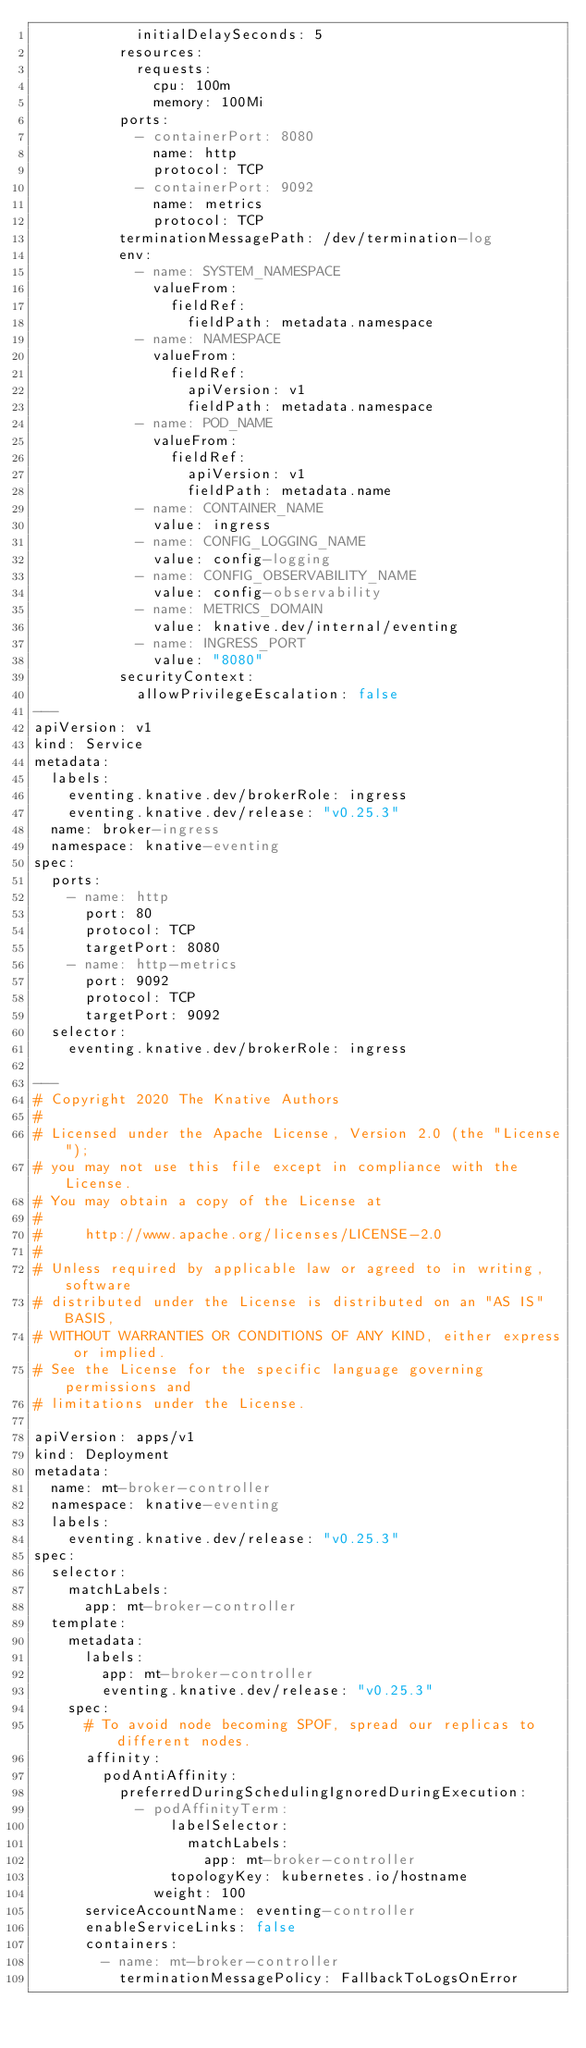Convert code to text. <code><loc_0><loc_0><loc_500><loc_500><_YAML_>            initialDelaySeconds: 5
          resources:
            requests:
              cpu: 100m
              memory: 100Mi
          ports:
            - containerPort: 8080
              name: http
              protocol: TCP
            - containerPort: 9092
              name: metrics
              protocol: TCP
          terminationMessagePath: /dev/termination-log
          env:
            - name: SYSTEM_NAMESPACE
              valueFrom:
                fieldRef:
                  fieldPath: metadata.namespace
            - name: NAMESPACE
              valueFrom:
                fieldRef:
                  apiVersion: v1
                  fieldPath: metadata.namespace
            - name: POD_NAME
              valueFrom:
                fieldRef:
                  apiVersion: v1
                  fieldPath: metadata.name
            - name: CONTAINER_NAME
              value: ingress
            - name: CONFIG_LOGGING_NAME
              value: config-logging
            - name: CONFIG_OBSERVABILITY_NAME
              value: config-observability
            - name: METRICS_DOMAIN
              value: knative.dev/internal/eventing
            - name: INGRESS_PORT
              value: "8080"
          securityContext:
            allowPrivilegeEscalation: false
---
apiVersion: v1
kind: Service
metadata:
  labels:
    eventing.knative.dev/brokerRole: ingress
    eventing.knative.dev/release: "v0.25.3"
  name: broker-ingress
  namespace: knative-eventing
spec:
  ports:
    - name: http
      port: 80
      protocol: TCP
      targetPort: 8080
    - name: http-metrics
      port: 9092
      protocol: TCP
      targetPort: 9092
  selector:
    eventing.knative.dev/brokerRole: ingress

---
# Copyright 2020 The Knative Authors
#
# Licensed under the Apache License, Version 2.0 (the "License");
# you may not use this file except in compliance with the License.
# You may obtain a copy of the License at
#
#     http://www.apache.org/licenses/LICENSE-2.0
#
# Unless required by applicable law or agreed to in writing, software
# distributed under the License is distributed on an "AS IS" BASIS,
# WITHOUT WARRANTIES OR CONDITIONS OF ANY KIND, either express or implied.
# See the License for the specific language governing permissions and
# limitations under the License.

apiVersion: apps/v1
kind: Deployment
metadata:
  name: mt-broker-controller
  namespace: knative-eventing
  labels:
    eventing.knative.dev/release: "v0.25.3"
spec:
  selector:
    matchLabels:
      app: mt-broker-controller
  template:
    metadata:
      labels:
        app: mt-broker-controller
        eventing.knative.dev/release: "v0.25.3"
    spec:
      # To avoid node becoming SPOF, spread our replicas to different nodes.
      affinity:
        podAntiAffinity:
          preferredDuringSchedulingIgnoredDuringExecution:
            - podAffinityTerm:
                labelSelector:
                  matchLabels:
                    app: mt-broker-controller
                topologyKey: kubernetes.io/hostname
              weight: 100
      serviceAccountName: eventing-controller
      enableServiceLinks: false
      containers:
        - name: mt-broker-controller
          terminationMessagePolicy: FallbackToLogsOnError</code> 